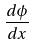<formula> <loc_0><loc_0><loc_500><loc_500>\frac { d \phi } { d x }</formula> 